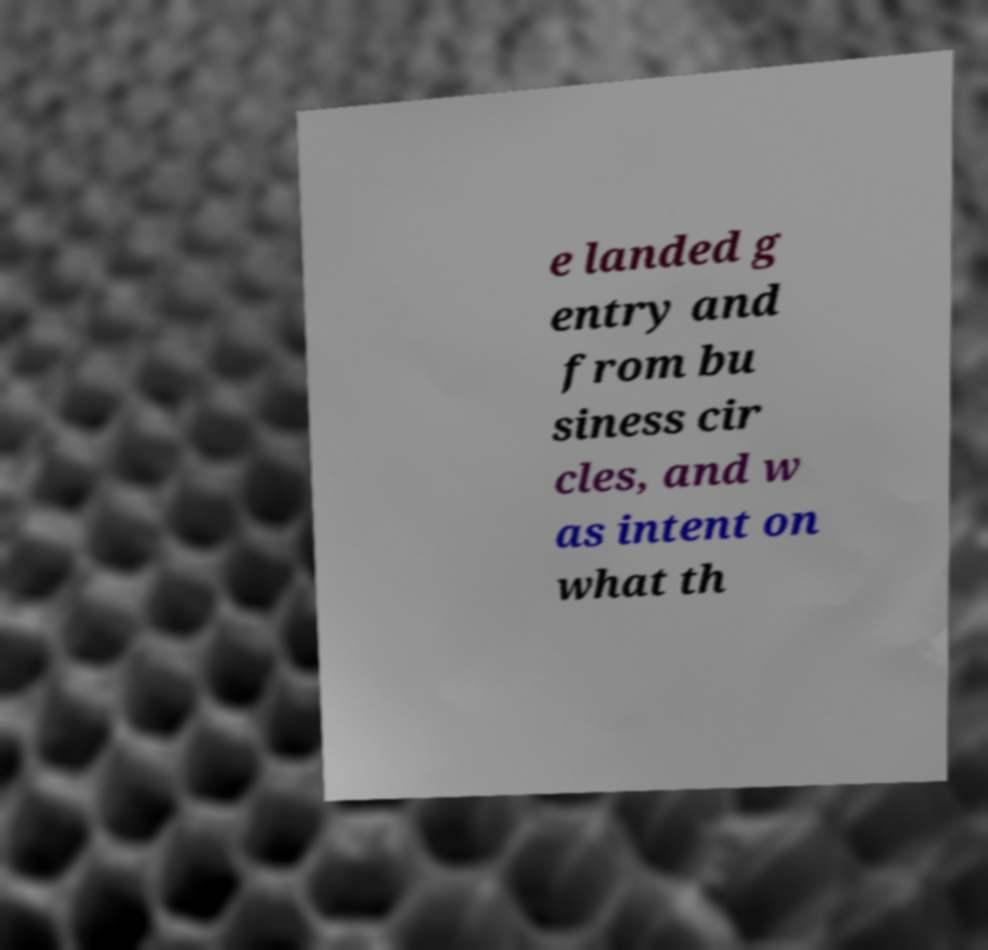I need the written content from this picture converted into text. Can you do that? e landed g entry and from bu siness cir cles, and w as intent on what th 